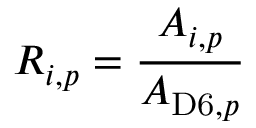Convert formula to latex. <formula><loc_0><loc_0><loc_500><loc_500>R _ { i , p } = \frac { A _ { i , p } } { A _ { D 6 , { p } } }</formula> 